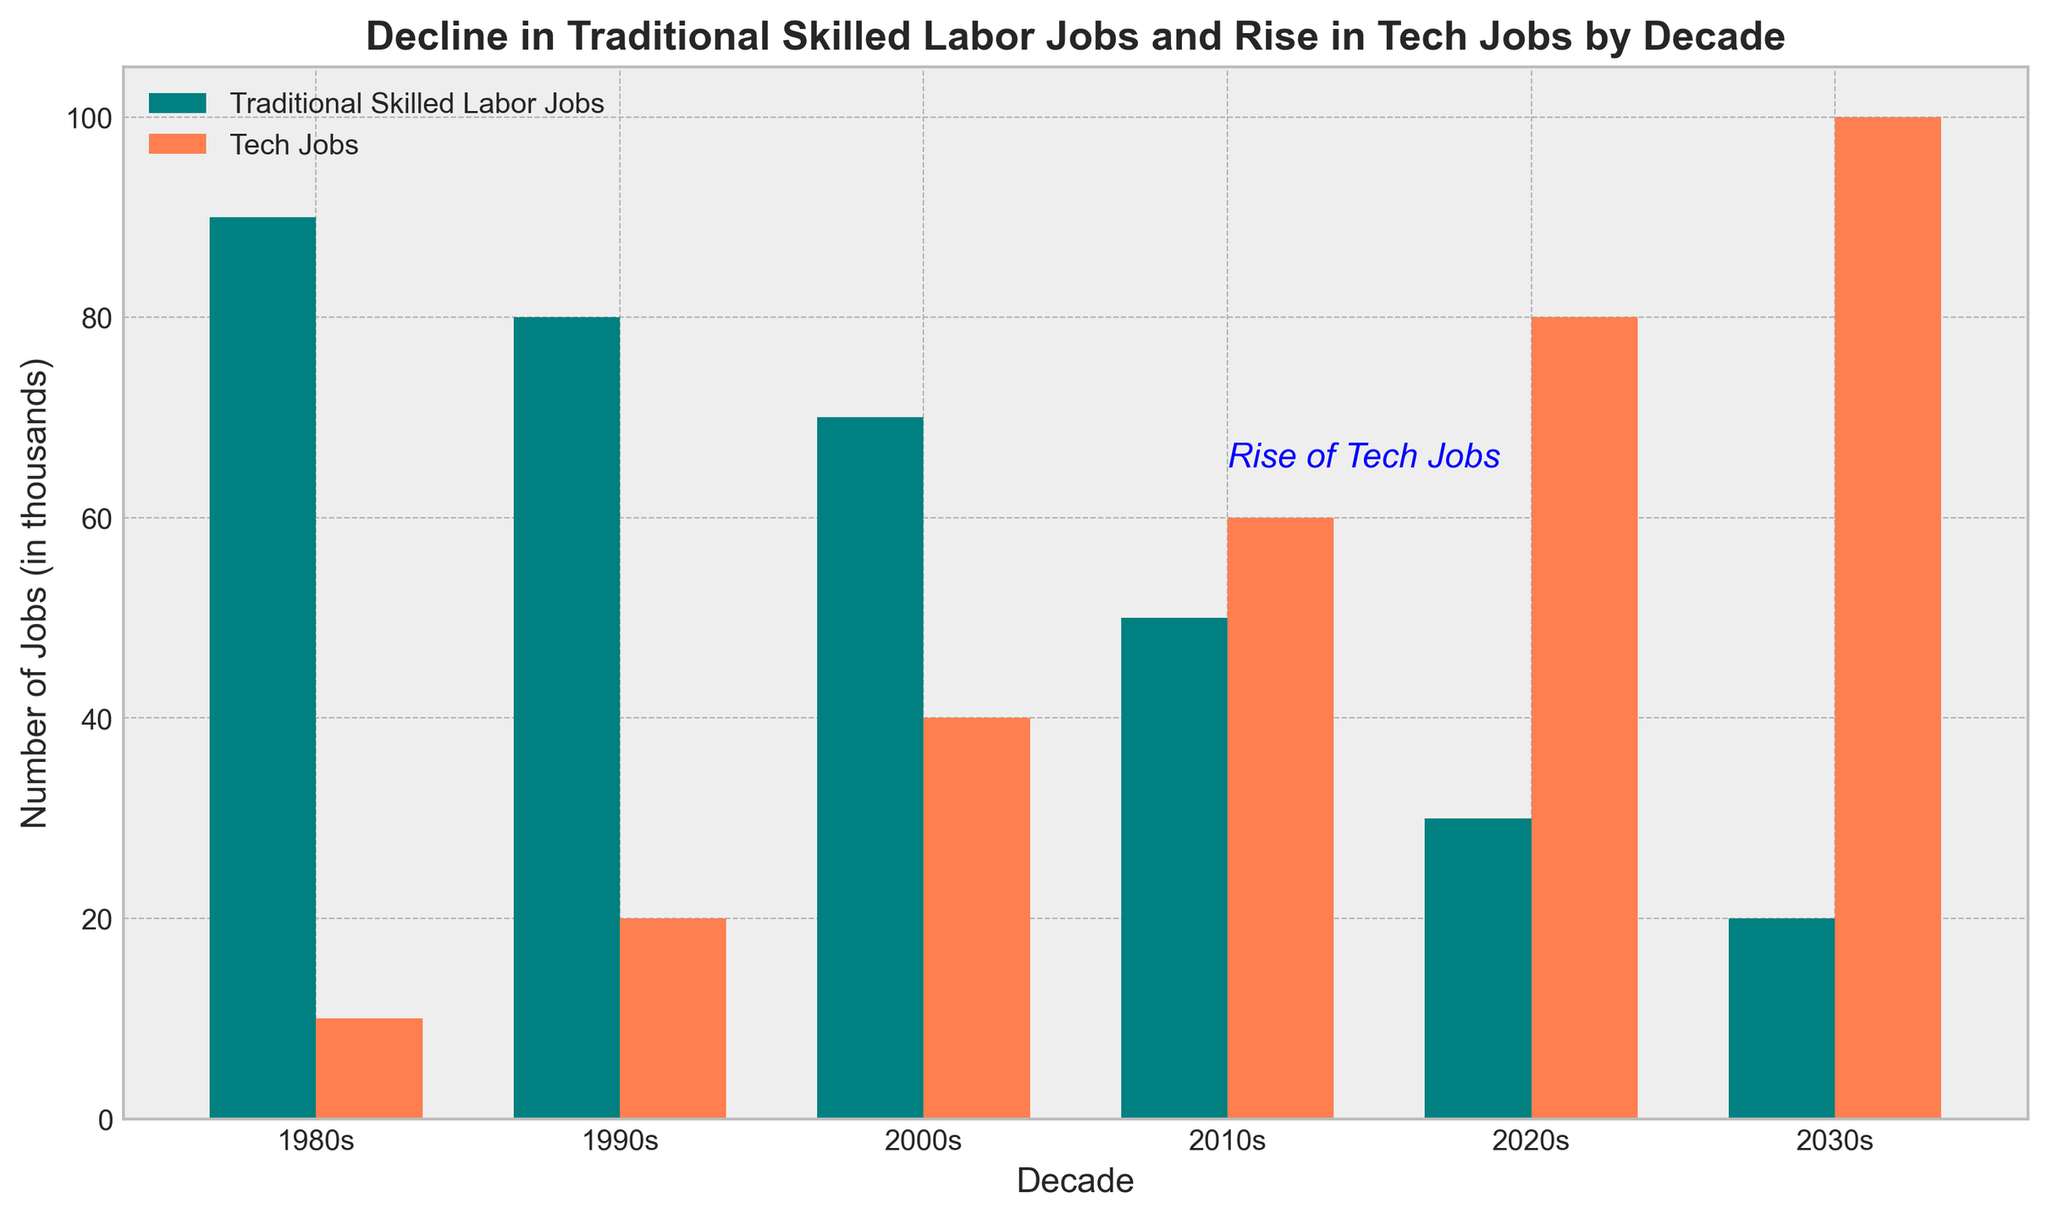What is the title of the chart? The title of the chart is located at the top and reads "Decline in Traditional Skilled Labor Jobs and Rise in Tech Jobs by Decade."
Answer: Decline in Traditional Skilled Labor Jobs and Rise in Tech Jobs by Decade Which decade saw an equal number of traditional skilled labor jobs and tech jobs? By comparing the heights of the bars, we can see that both traditional skilled labor jobs and tech jobs each have a height of 60 in the 2010s.
Answer: 2010s How many traditional skilled labor jobs were there in the 1990s compared to the 2030s? The bar for traditional skilled labor jobs in the 1990s is at 80, whereas in the 2030s, it is at 20. The difference is 80 - 20 = 60.
Answer: 60 more in 1990s What is the trend in tech jobs from the 1980s to the 2030s? Observing the bars for tech jobs, we can see an increasing trend. The values are 10 (1980s), 20 (1990s), 40 (2000s), 60 (2010s), 80 (2020s), and 100 (2030s).
Answer: Increasing Which decade had the largest number of traditional skilled labor jobs? By looking at the bars for traditional skilled labor jobs, the highest bar is in the 1980s.
Answer: 1980s What is the difference in the number of tech jobs between the 2020s and 1980s? The height of the bar for tech jobs in the 2020s is 80, and in the 1980s, it is 10. So, the difference is 80 - 10 = 70.
Answer: 70 How do the lengths of the bars for traditional skilled labor jobs in the 2000s compare to tech jobs in the same decade? The bar for traditional skilled labor jobs in the 2000s is at 70, while the bar for tech jobs is at 40, meaning the traditional skilled labor job bar is significantly taller.
Answer: Traditional skilled labor jobs are taller What does the blue text annotation in the chart indicate? The blue text annotation "Rise of Tech Jobs" is placed at the level where the tech jobs exceed traditional skilled labor jobs, indicating the rise in tech jobs from the 2010s onwards.
Answer: Rise of Tech Jobs What has happened to the number of traditional skilled labor jobs from the 1980s to the 2030s? The bars for traditional skilled labor jobs show a decline over the decades, with values decreasing from 90 in the 1980s to 20 in the 2030s.
Answer: Declined Considering the total number of jobs (both traditional and tech) in the 2020s, what is the combined number? Adding the heights of the bars for both traditional skilled labor jobs (30) and tech jobs (80) in the 2020s, we get 30 + 80 = 110.
Answer: 110 